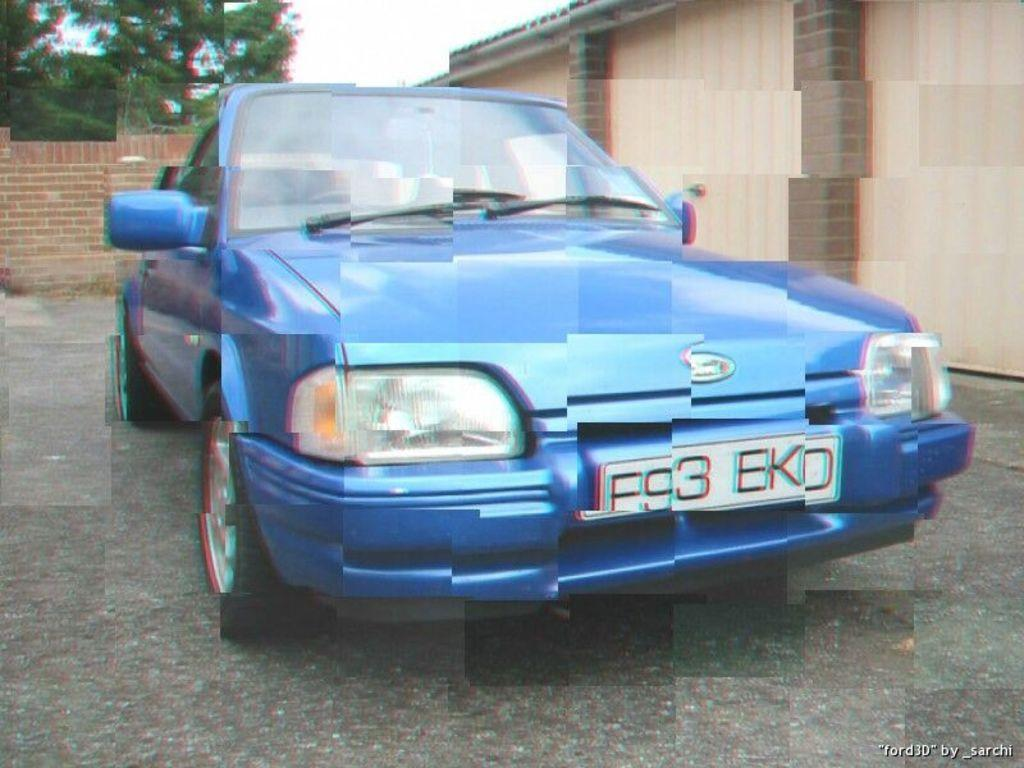What is the main subject of the image? The main subject of the image is a car. Where is the car located in the image? The car is on the road in the image. What can be seen in the background of the image? There are trees and a shed visible in the background of the image. What type of picture is hanging on the wall inside the shed in the image? There is no information about a picture hanging on the wall inside the shed in the image. Additionally, the image does not show the inside of the shed. 